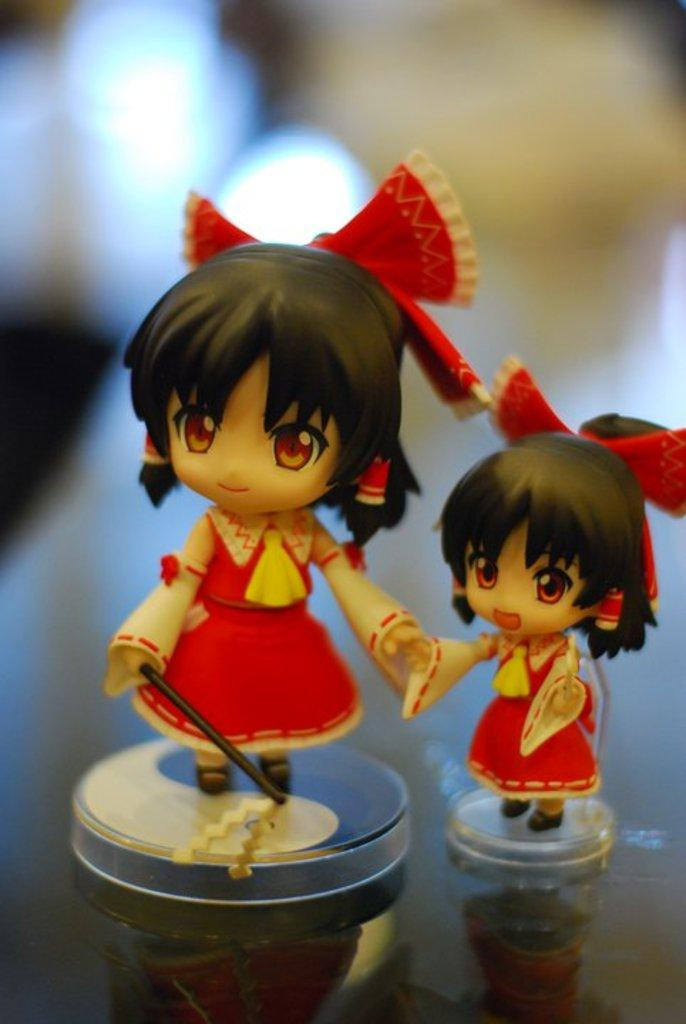How many toys are present in the image? There are two toys in the image. What colors can be seen on the toys? The toys are red, yellow, cream, and black in color. What is the surface on which the toys are placed? The toys are on a black-colored glass surface. Can you describe the background of the image? A: The background of the image is blurry. How many fish are swimming in the image? There are no fish present in the image; it features two toys on a black-colored glass surface. 